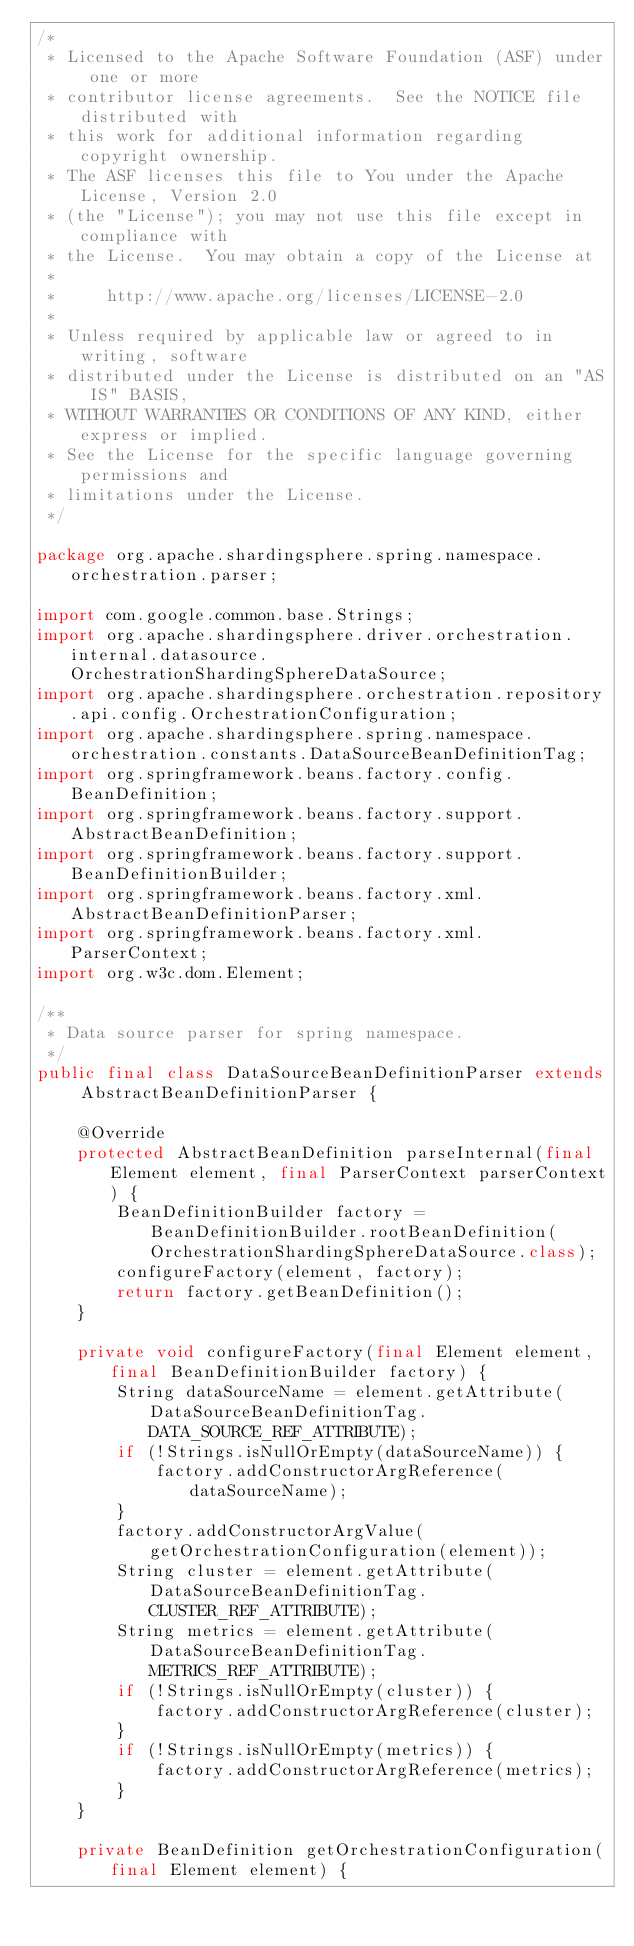Convert code to text. <code><loc_0><loc_0><loc_500><loc_500><_Java_>/*
 * Licensed to the Apache Software Foundation (ASF) under one or more
 * contributor license agreements.  See the NOTICE file distributed with
 * this work for additional information regarding copyright ownership.
 * The ASF licenses this file to You under the Apache License, Version 2.0
 * (the "License"); you may not use this file except in compliance with
 * the License.  You may obtain a copy of the License at
 *
 *     http://www.apache.org/licenses/LICENSE-2.0
 *
 * Unless required by applicable law or agreed to in writing, software
 * distributed under the License is distributed on an "AS IS" BASIS,
 * WITHOUT WARRANTIES OR CONDITIONS OF ANY KIND, either express or implied.
 * See the License for the specific language governing permissions and
 * limitations under the License.
 */

package org.apache.shardingsphere.spring.namespace.orchestration.parser;

import com.google.common.base.Strings;
import org.apache.shardingsphere.driver.orchestration.internal.datasource.OrchestrationShardingSphereDataSource;
import org.apache.shardingsphere.orchestration.repository.api.config.OrchestrationConfiguration;
import org.apache.shardingsphere.spring.namespace.orchestration.constants.DataSourceBeanDefinitionTag;
import org.springframework.beans.factory.config.BeanDefinition;
import org.springframework.beans.factory.support.AbstractBeanDefinition;
import org.springframework.beans.factory.support.BeanDefinitionBuilder;
import org.springframework.beans.factory.xml.AbstractBeanDefinitionParser;
import org.springframework.beans.factory.xml.ParserContext;
import org.w3c.dom.Element;

/**
 * Data source parser for spring namespace.
 */
public final class DataSourceBeanDefinitionParser extends AbstractBeanDefinitionParser {
    
    @Override
    protected AbstractBeanDefinition parseInternal(final Element element, final ParserContext parserContext) {
        BeanDefinitionBuilder factory = BeanDefinitionBuilder.rootBeanDefinition(OrchestrationShardingSphereDataSource.class);
        configureFactory(element, factory);
        return factory.getBeanDefinition();
    }
    
    private void configureFactory(final Element element, final BeanDefinitionBuilder factory) {
        String dataSourceName = element.getAttribute(DataSourceBeanDefinitionTag.DATA_SOURCE_REF_ATTRIBUTE);
        if (!Strings.isNullOrEmpty(dataSourceName)) {
            factory.addConstructorArgReference(dataSourceName);
        }
        factory.addConstructorArgValue(getOrchestrationConfiguration(element));
        String cluster = element.getAttribute(DataSourceBeanDefinitionTag.CLUSTER_REF_ATTRIBUTE);
        String metrics = element.getAttribute(DataSourceBeanDefinitionTag.METRICS_REF_ATTRIBUTE);
        if (!Strings.isNullOrEmpty(cluster)) {
            factory.addConstructorArgReference(cluster);
        }
        if (!Strings.isNullOrEmpty(metrics)) {
            factory.addConstructorArgReference(metrics);
        }
    }
    
    private BeanDefinition getOrchestrationConfiguration(final Element element) {</code> 